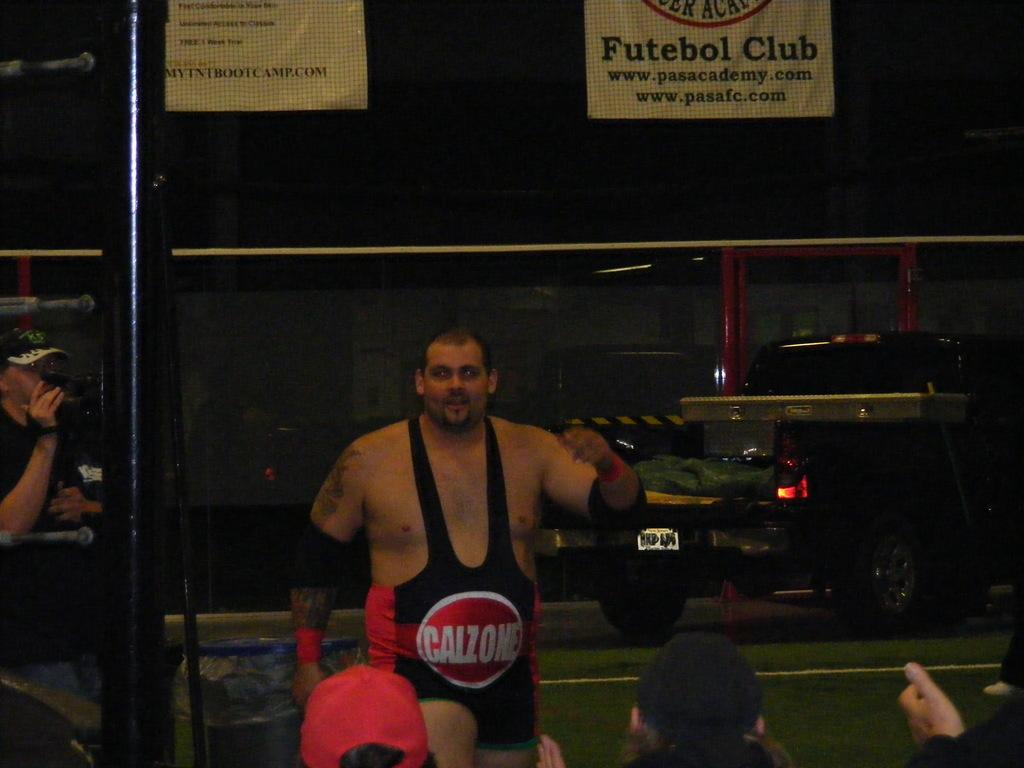<image>
Share a concise interpretation of the image provided. Man with a Calzone sign on his outfit is walking 